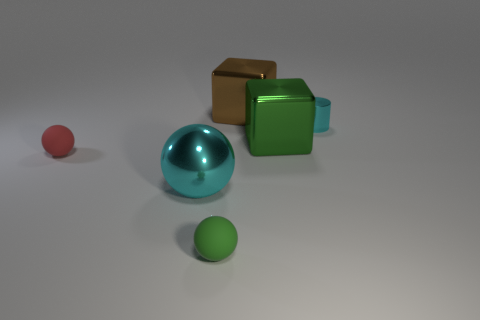What size is the metallic cylinder that is the same color as the big metal sphere?
Ensure brevity in your answer.  Small. Are there any small metal cylinders of the same color as the big shiny ball?
Your answer should be compact. Yes. Is the color of the shiny ball the same as the small thing to the right of the green rubber object?
Give a very brief answer. Yes. Does the small object that is right of the big brown thing have the same color as the metal ball?
Offer a very short reply. Yes. There is a thing that is the same color as the big shiny sphere; what shape is it?
Ensure brevity in your answer.  Cylinder. There is a small cylinder that is the same color as the big metal ball; what is it made of?
Ensure brevity in your answer.  Metal. What number of other objects are there of the same color as the shiny ball?
Offer a very short reply. 1. What material is the cyan thing that is behind the ball on the left side of the large cyan ball?
Provide a short and direct response. Metal. There is a cyan thing that is the same size as the green block; what is its material?
Ensure brevity in your answer.  Metal. Does the rubber object behind the shiny ball have the same size as the cylinder?
Make the answer very short. Yes. 